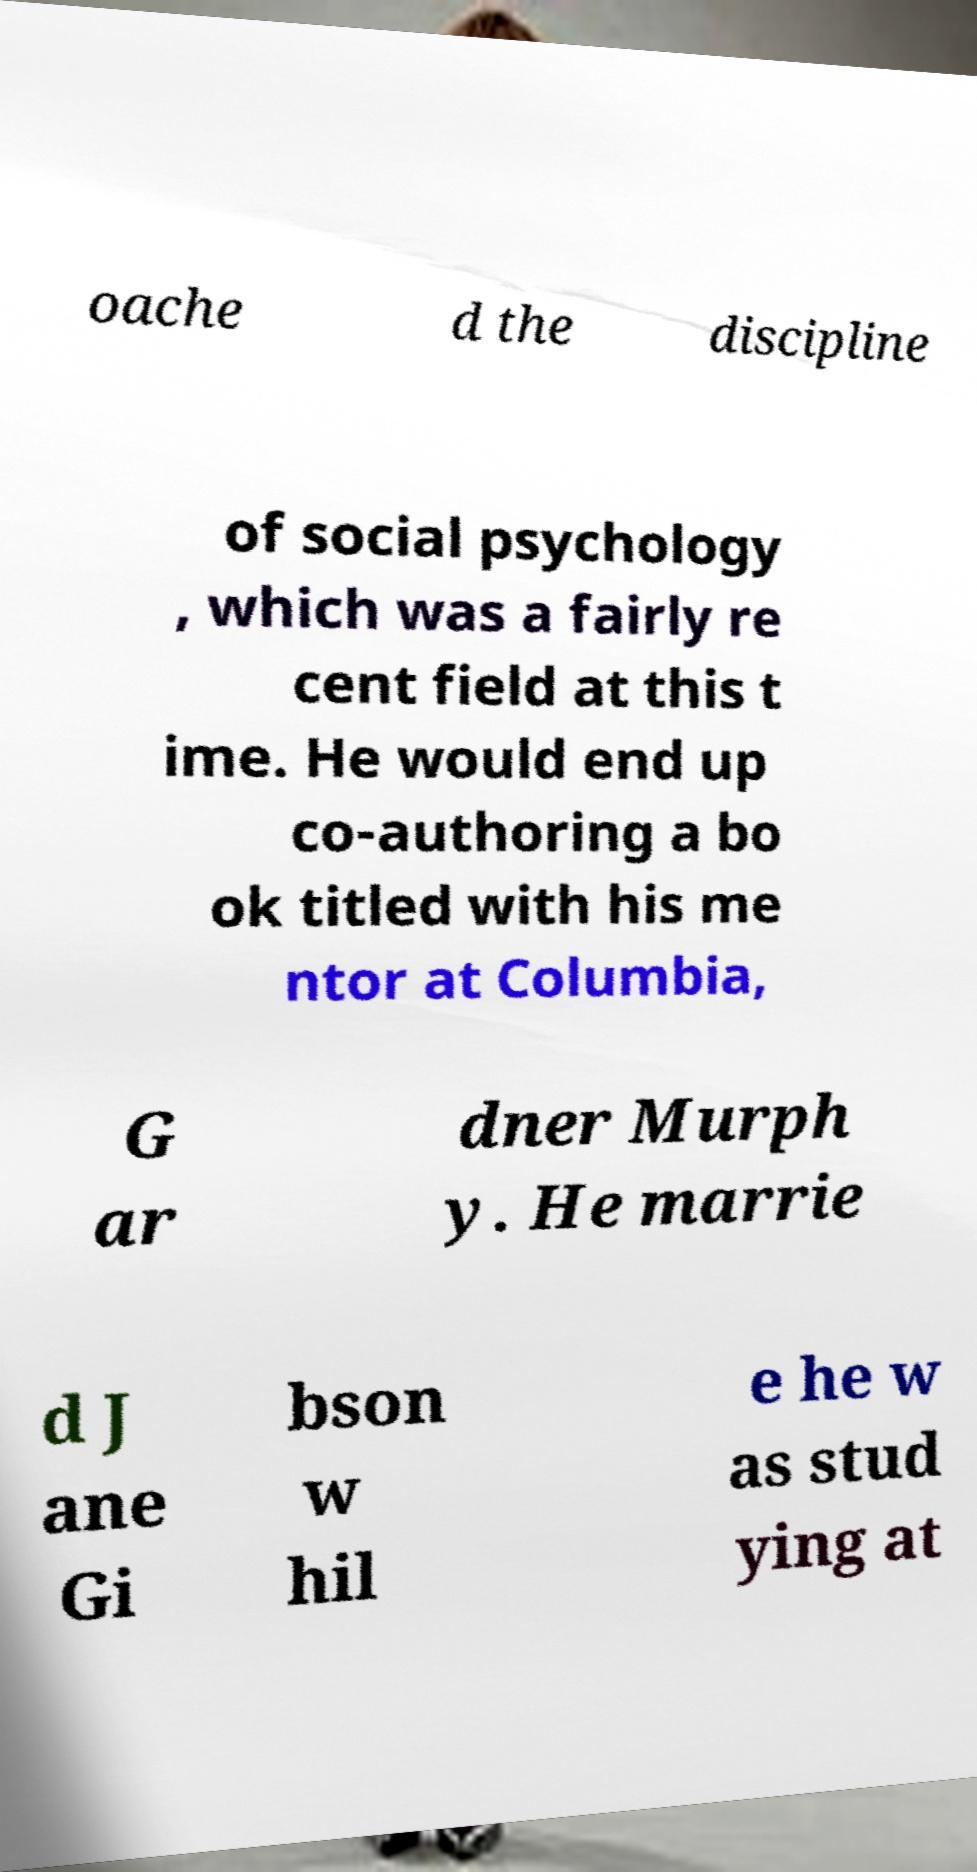Could you assist in decoding the text presented in this image and type it out clearly? oache d the discipline of social psychology , which was a fairly re cent field at this t ime. He would end up co-authoring a bo ok titled with his me ntor at Columbia, G ar dner Murph y. He marrie d J ane Gi bson w hil e he w as stud ying at 